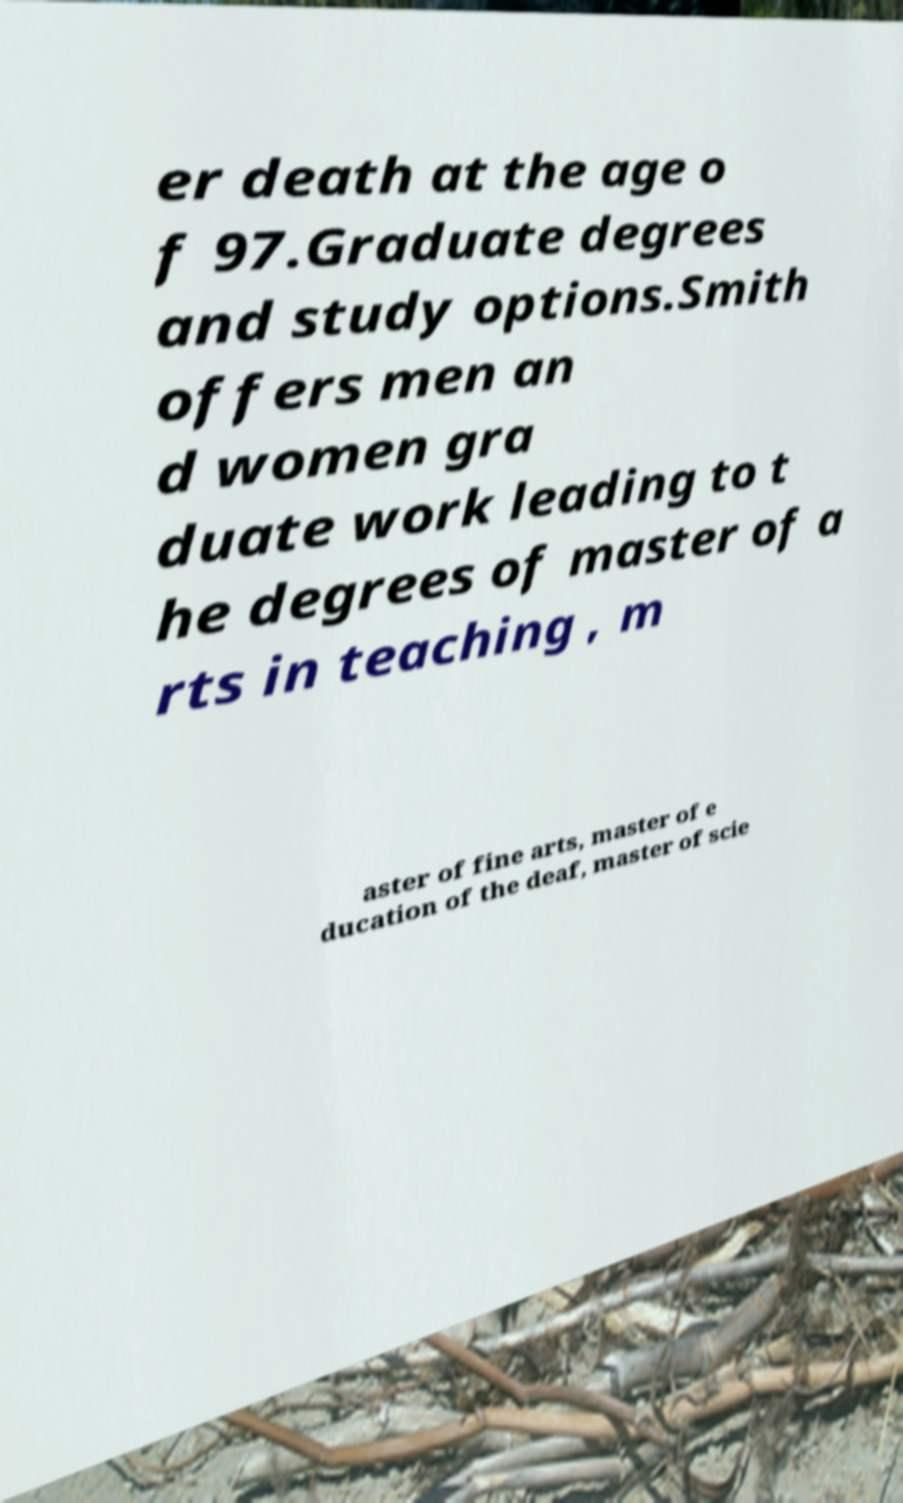Can you read and provide the text displayed in the image?This photo seems to have some interesting text. Can you extract and type it out for me? er death at the age o f 97.Graduate degrees and study options.Smith offers men an d women gra duate work leading to t he degrees of master of a rts in teaching , m aster of fine arts, master of e ducation of the deaf, master of scie 